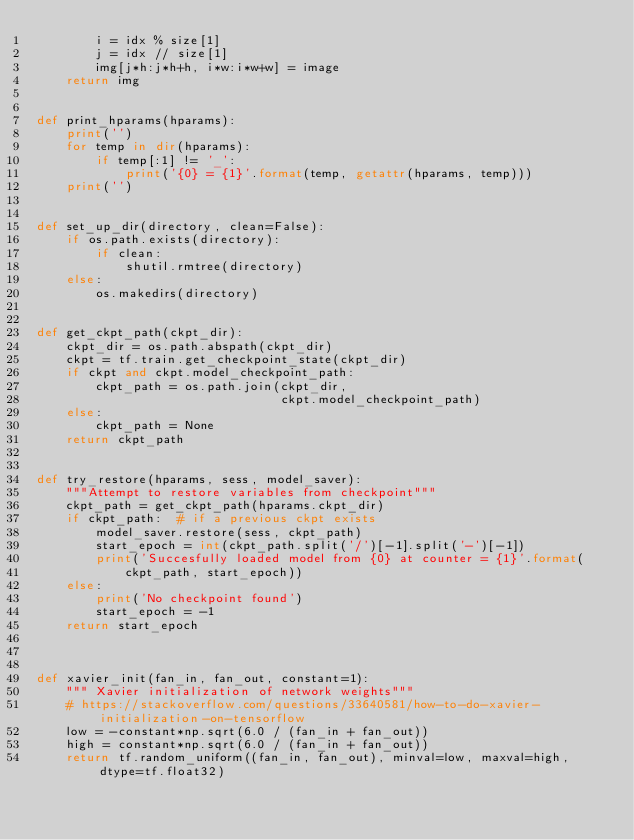<code> <loc_0><loc_0><loc_500><loc_500><_Python_>        i = idx % size[1]
        j = idx // size[1]
        img[j*h:j*h+h, i*w:i*w+w] = image
    return img


def print_hparams(hparams):
    print('')
    for temp in dir(hparams):
        if temp[:1] != '_':
            print('{0} = {1}'.format(temp, getattr(hparams, temp)))
    print('')


def set_up_dir(directory, clean=False):
    if os.path.exists(directory):
        if clean:
            shutil.rmtree(directory)
    else:
        os.makedirs(directory)


def get_ckpt_path(ckpt_dir):
    ckpt_dir = os.path.abspath(ckpt_dir)
    ckpt = tf.train.get_checkpoint_state(ckpt_dir)
    if ckpt and ckpt.model_checkpoint_path:
        ckpt_path = os.path.join(ckpt_dir,
                                 ckpt.model_checkpoint_path)
    else:
        ckpt_path = None
    return ckpt_path


def try_restore(hparams, sess, model_saver):
    """Attempt to restore variables from checkpoint"""
    ckpt_path = get_ckpt_path(hparams.ckpt_dir)
    if ckpt_path:  # if a previous ckpt exists
        model_saver.restore(sess, ckpt_path)
        start_epoch = int(ckpt_path.split('/')[-1].split('-')[-1])
        print('Succesfully loaded model from {0} at counter = {1}'.format(
            ckpt_path, start_epoch))
    else:
        print('No checkpoint found')
        start_epoch = -1
    return start_epoch



def xavier_init(fan_in, fan_out, constant=1):
    """ Xavier initialization of network weights"""
    # https://stackoverflow.com/questions/33640581/how-to-do-xavier-initialization-on-tensorflow
    low = -constant*np.sqrt(6.0 / (fan_in + fan_out))
    high = constant*np.sqrt(6.0 / (fan_in + fan_out))
    return tf.random_uniform((fan_in, fan_out), minval=low, maxval=high, dtype=tf.float32)
</code> 